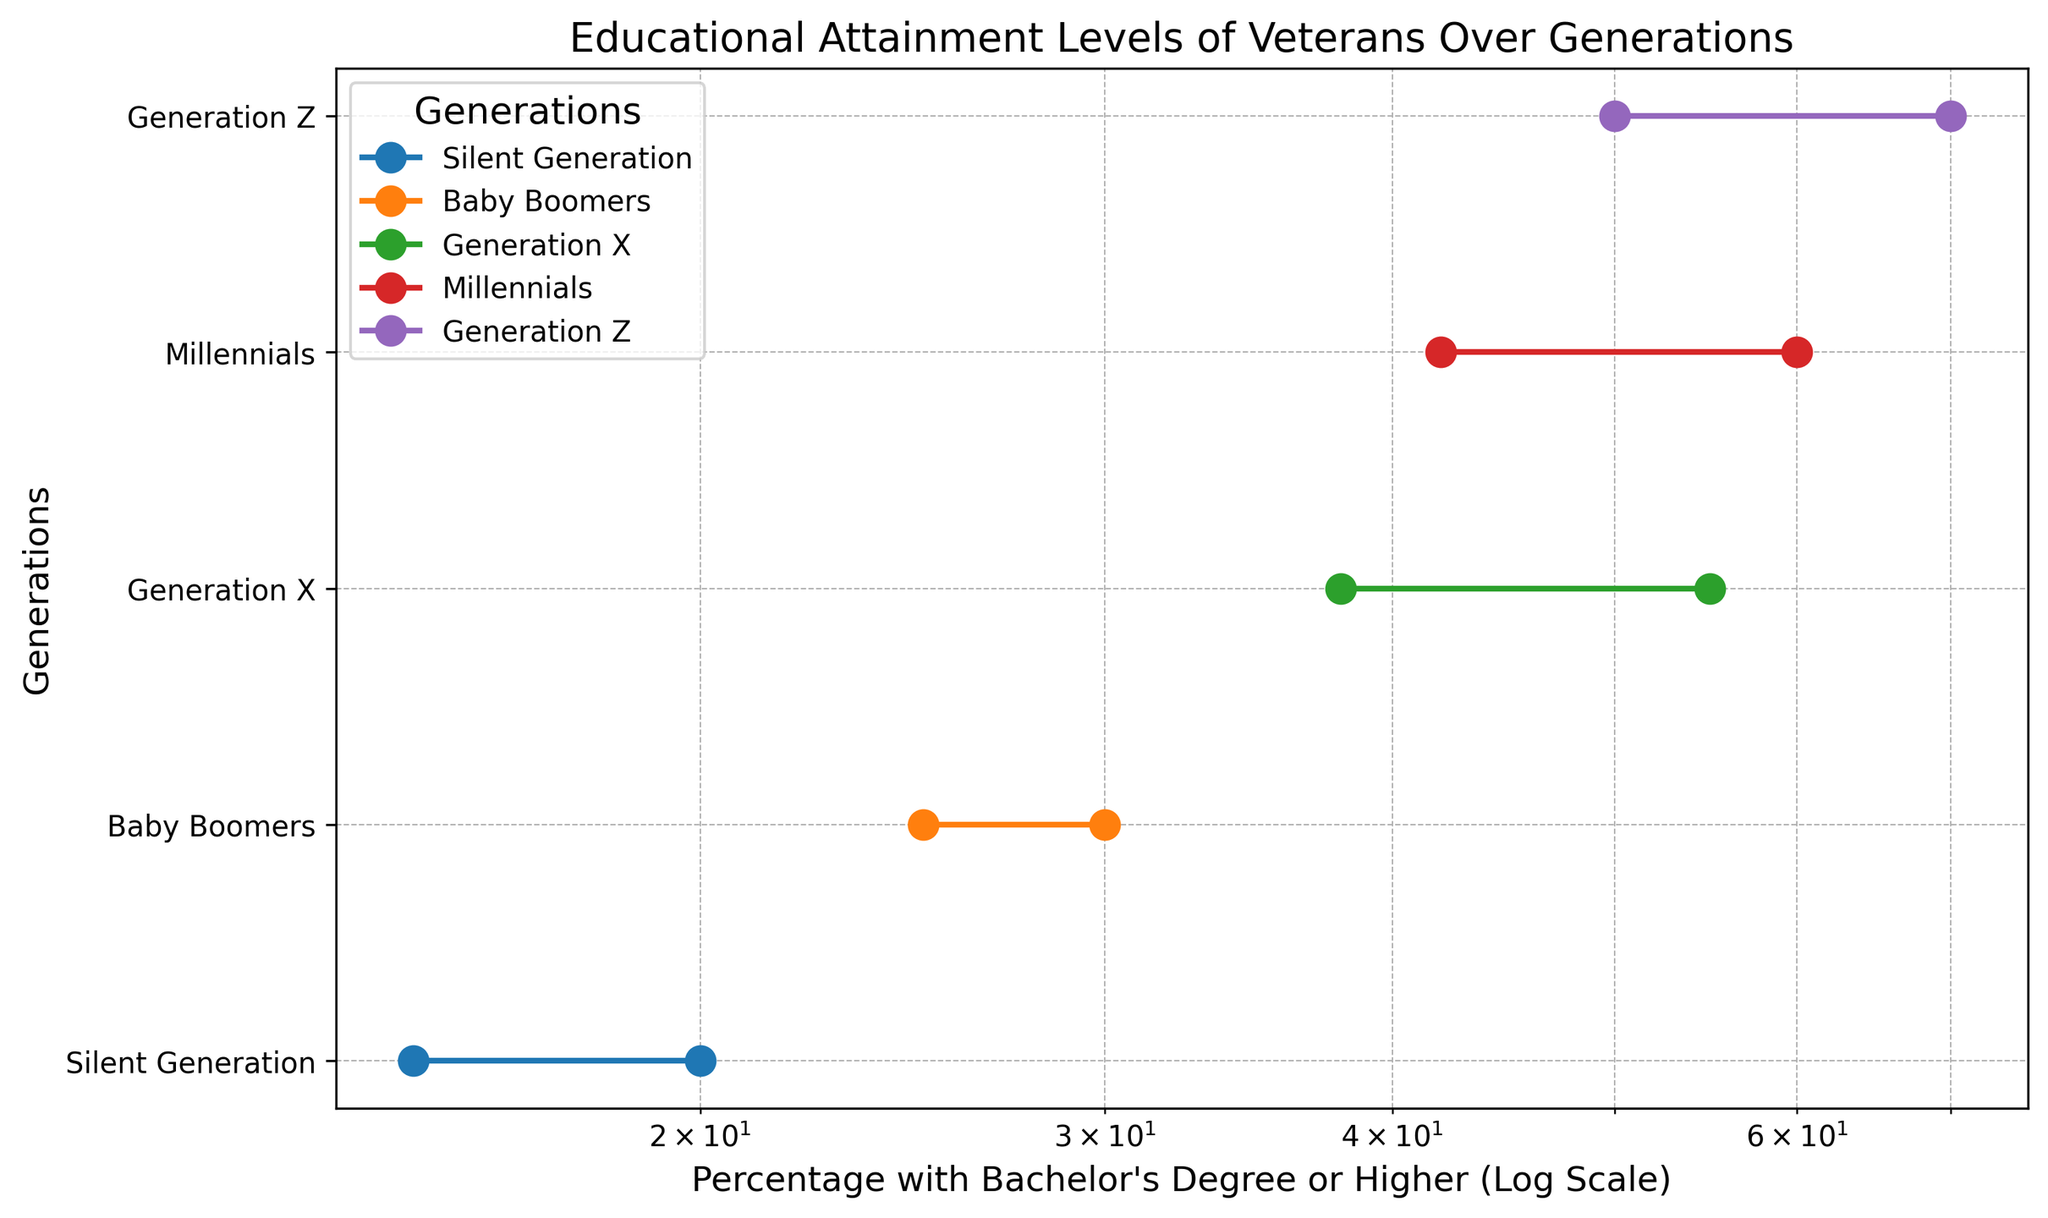Which generation has the highest percentage of veterans with a bachelor's degree or higher? By looking at the plot, we can see that Generation Z reaches the highest percentage on the x-axis for both instances provided, showing a significant education level amongst veterans of that generation.
Answer: Generation Z How does the percentage of veterans with a bachelor's degree or higher change from the Silent Generation to Generation Z? The graph shows an increasing trend from the Silent Generation to Generation Z. For one instance of data, it goes from 15% to 50%, and for another, it goes from 20% to 70%.
Answer: It increases What is the difference in the percentage of veterans with a bachelor's degree or higher between Millennials and Baby Boomers? By analyzing the plot, we see that the percentage for Millennials is higher than that for Baby Boomers. For one instance, it's 42% for Millennials and 25% for Baby Boomers, and for another instance, it's 60% for Millennials and 30% for Baby Boomers.
Answer: 17% and 30% Which generation sees the greatest single generational increase in the percentage of veterans with a bachelor's degree or higher? By comparing the differences between adjacent generations on the plot, the greatest increase is from Baby Boomers to Generation X. In one dataset, it increases from 25% to 38% (13%), and in the other, from 30% to 55% (25%).
Answer: Generation X Considering a logscale x-axis, how do the visual distances between generations reflect their educational advancement? On a log scale, equal distances on the axis represent multiplicative changes rather than additive. Therefore, larger visual gaps represent substantial multiplicative increases in educational attainment percentages, notably seen between some generations like Baby Boomers and Generation X.
Answer: Multiplicative increases Which generations overlapped in the data provided? The data shows overlapping data points for each generation which are plotted with different percentages for the same generation names across the plot, indicating that there were multiple records for each generation.
Answer: All generations How does the trend of educational attainment differ across the two instances plotted? In both plots, there is a consistent increase in educational attainment percentage from older to younger generations, but the specific values differ. One trend starts from 15% to 50%, and the other from 20% to 70%. The rate of increase is more pronounced in the second instance.
Answer: Consistent increase, different rates What can you infer about the educational trend among veterans over generations? Both instances in the plot show a clear upward trend, indicating that educational attainment among veterans has substantially increased from the Silent Generation to Generation Z, reflecting an increased emphasis on higher education over time.
Answer: Upward trend Is there any evidence of a generational plateau in educational attainment among veterans? Based on the plot, there are no indications of a plateau; each successive generation has higher percentages than the previous ones, indicating continuous growth without leveling off.
Answer: No plateau 